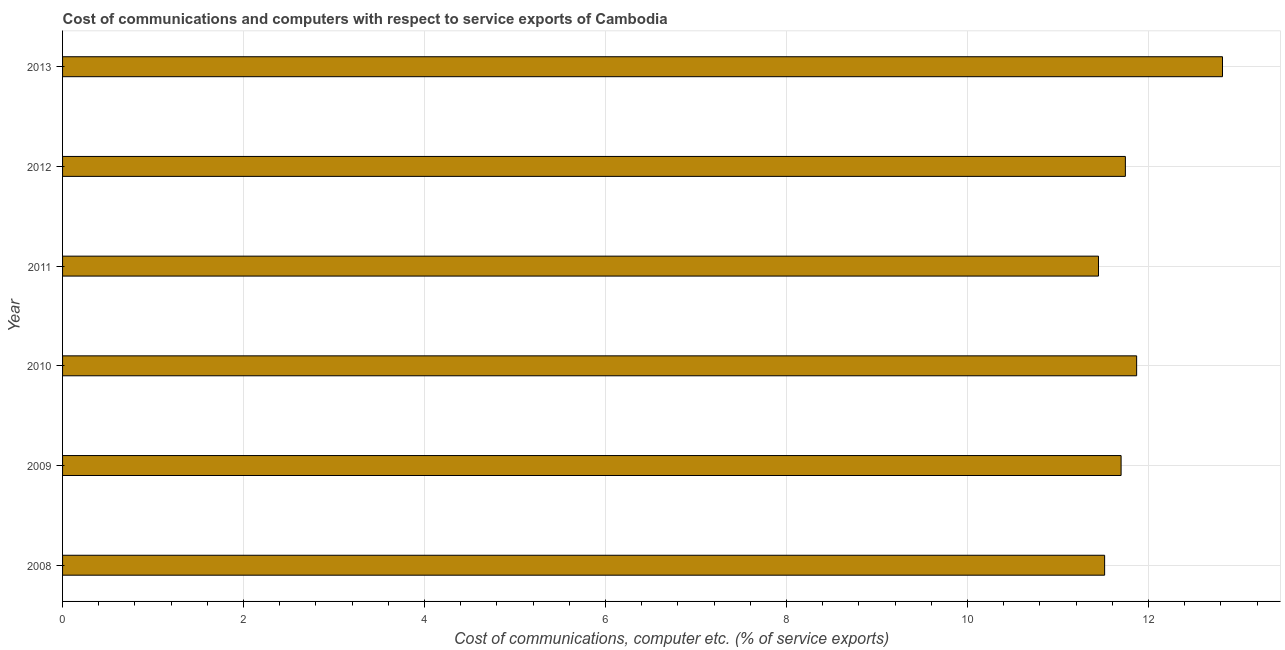Does the graph contain grids?
Your answer should be compact. Yes. What is the title of the graph?
Your response must be concise. Cost of communications and computers with respect to service exports of Cambodia. What is the label or title of the X-axis?
Give a very brief answer. Cost of communications, computer etc. (% of service exports). What is the label or title of the Y-axis?
Keep it short and to the point. Year. What is the cost of communications and computer in 2008?
Give a very brief answer. 11.52. Across all years, what is the maximum cost of communications and computer?
Your response must be concise. 12.82. Across all years, what is the minimum cost of communications and computer?
Offer a terse response. 11.45. In which year was the cost of communications and computer maximum?
Provide a short and direct response. 2013. What is the sum of the cost of communications and computer?
Make the answer very short. 71.09. What is the difference between the cost of communications and computer in 2012 and 2013?
Give a very brief answer. -1.07. What is the average cost of communications and computer per year?
Give a very brief answer. 11.85. What is the median cost of communications and computer?
Your response must be concise. 11.72. In how many years, is the cost of communications and computer greater than 4.8 %?
Give a very brief answer. 6. What is the ratio of the cost of communications and computer in 2012 to that in 2013?
Your response must be concise. 0.92. Is the cost of communications and computer in 2010 less than that in 2011?
Give a very brief answer. No. What is the difference between the highest and the second highest cost of communications and computer?
Give a very brief answer. 0.95. What is the difference between the highest and the lowest cost of communications and computer?
Offer a terse response. 1.37. How many bars are there?
Keep it short and to the point. 6. What is the difference between two consecutive major ticks on the X-axis?
Your answer should be very brief. 2. Are the values on the major ticks of X-axis written in scientific E-notation?
Ensure brevity in your answer.  No. What is the Cost of communications, computer etc. (% of service exports) in 2008?
Give a very brief answer. 11.52. What is the Cost of communications, computer etc. (% of service exports) of 2009?
Your answer should be compact. 11.7. What is the Cost of communications, computer etc. (% of service exports) in 2010?
Provide a succinct answer. 11.87. What is the Cost of communications, computer etc. (% of service exports) of 2011?
Your answer should be compact. 11.45. What is the Cost of communications, computer etc. (% of service exports) of 2012?
Make the answer very short. 11.74. What is the Cost of communications, computer etc. (% of service exports) of 2013?
Offer a very short reply. 12.82. What is the difference between the Cost of communications, computer etc. (% of service exports) in 2008 and 2009?
Your answer should be compact. -0.18. What is the difference between the Cost of communications, computer etc. (% of service exports) in 2008 and 2010?
Ensure brevity in your answer.  -0.35. What is the difference between the Cost of communications, computer etc. (% of service exports) in 2008 and 2011?
Ensure brevity in your answer.  0.07. What is the difference between the Cost of communications, computer etc. (% of service exports) in 2008 and 2012?
Offer a terse response. -0.23. What is the difference between the Cost of communications, computer etc. (% of service exports) in 2008 and 2013?
Provide a succinct answer. -1.3. What is the difference between the Cost of communications, computer etc. (% of service exports) in 2009 and 2010?
Ensure brevity in your answer.  -0.17. What is the difference between the Cost of communications, computer etc. (% of service exports) in 2009 and 2011?
Ensure brevity in your answer.  0.25. What is the difference between the Cost of communications, computer etc. (% of service exports) in 2009 and 2012?
Your answer should be very brief. -0.05. What is the difference between the Cost of communications, computer etc. (% of service exports) in 2009 and 2013?
Provide a succinct answer. -1.12. What is the difference between the Cost of communications, computer etc. (% of service exports) in 2010 and 2011?
Your response must be concise. 0.42. What is the difference between the Cost of communications, computer etc. (% of service exports) in 2010 and 2012?
Ensure brevity in your answer.  0.12. What is the difference between the Cost of communications, computer etc. (% of service exports) in 2010 and 2013?
Your answer should be compact. -0.95. What is the difference between the Cost of communications, computer etc. (% of service exports) in 2011 and 2012?
Provide a short and direct response. -0.3. What is the difference between the Cost of communications, computer etc. (% of service exports) in 2011 and 2013?
Provide a short and direct response. -1.37. What is the difference between the Cost of communications, computer etc. (% of service exports) in 2012 and 2013?
Make the answer very short. -1.07. What is the ratio of the Cost of communications, computer etc. (% of service exports) in 2008 to that in 2009?
Your response must be concise. 0.98. What is the ratio of the Cost of communications, computer etc. (% of service exports) in 2008 to that in 2010?
Provide a succinct answer. 0.97. What is the ratio of the Cost of communications, computer etc. (% of service exports) in 2008 to that in 2011?
Make the answer very short. 1.01. What is the ratio of the Cost of communications, computer etc. (% of service exports) in 2008 to that in 2013?
Give a very brief answer. 0.9. What is the ratio of the Cost of communications, computer etc. (% of service exports) in 2009 to that in 2010?
Keep it short and to the point. 0.99. What is the ratio of the Cost of communications, computer etc. (% of service exports) in 2010 to that in 2011?
Keep it short and to the point. 1.04. What is the ratio of the Cost of communications, computer etc. (% of service exports) in 2010 to that in 2012?
Give a very brief answer. 1.01. What is the ratio of the Cost of communications, computer etc. (% of service exports) in 2010 to that in 2013?
Your answer should be compact. 0.93. What is the ratio of the Cost of communications, computer etc. (% of service exports) in 2011 to that in 2012?
Make the answer very short. 0.97. What is the ratio of the Cost of communications, computer etc. (% of service exports) in 2011 to that in 2013?
Give a very brief answer. 0.89. What is the ratio of the Cost of communications, computer etc. (% of service exports) in 2012 to that in 2013?
Your answer should be compact. 0.92. 